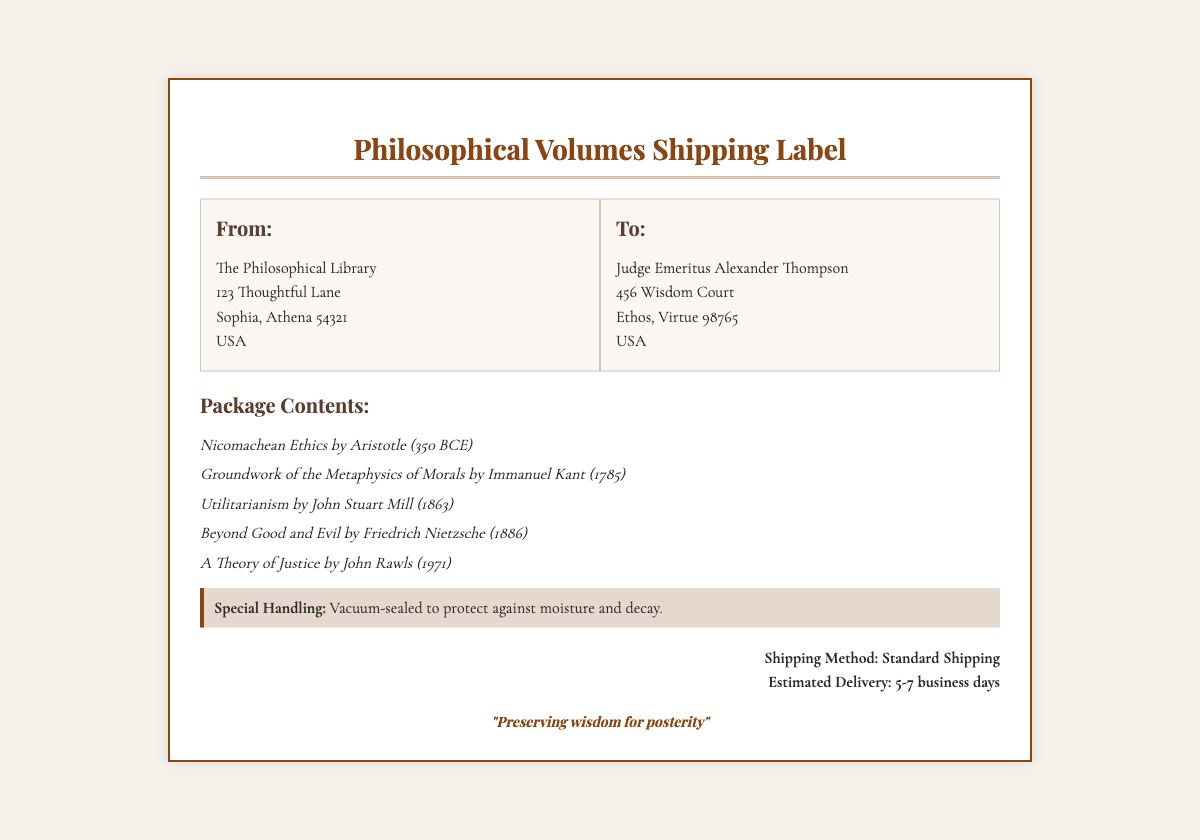what is the name of the sender? The sender's name is listed in the document under the "From" section.
Answer: The Philosophical Library who is the recipient of the shipment? The recipient's name is specified in the "To" section of the document.
Answer: Judge Emeritus Alexander Thompson what is the estimated delivery time? The estimated delivery time is noted in the shipping method section.
Answer: 5-7 business days which book was written by Aristotle? The document lists the contents of the package, including the author and title.
Answer: Nicomachean Ethics what special handling method is used for the package? The special handling information is provided in a specific section of the document.
Answer: Vacuum-sealed how many philosophical volumes are included in the shipment? The number of volumes can be counted from the package contents list in the document.
Answer: Five 